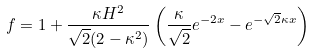<formula> <loc_0><loc_0><loc_500><loc_500>f = 1 + \frac { \kappa H ^ { 2 } } { \sqrt { 2 } ( 2 - \kappa ^ { 2 } ) } \left ( \frac { \kappa } { \sqrt { 2 } } e ^ { - 2 x } - e ^ { - \sqrt { 2 } \kappa x } \right )</formula> 